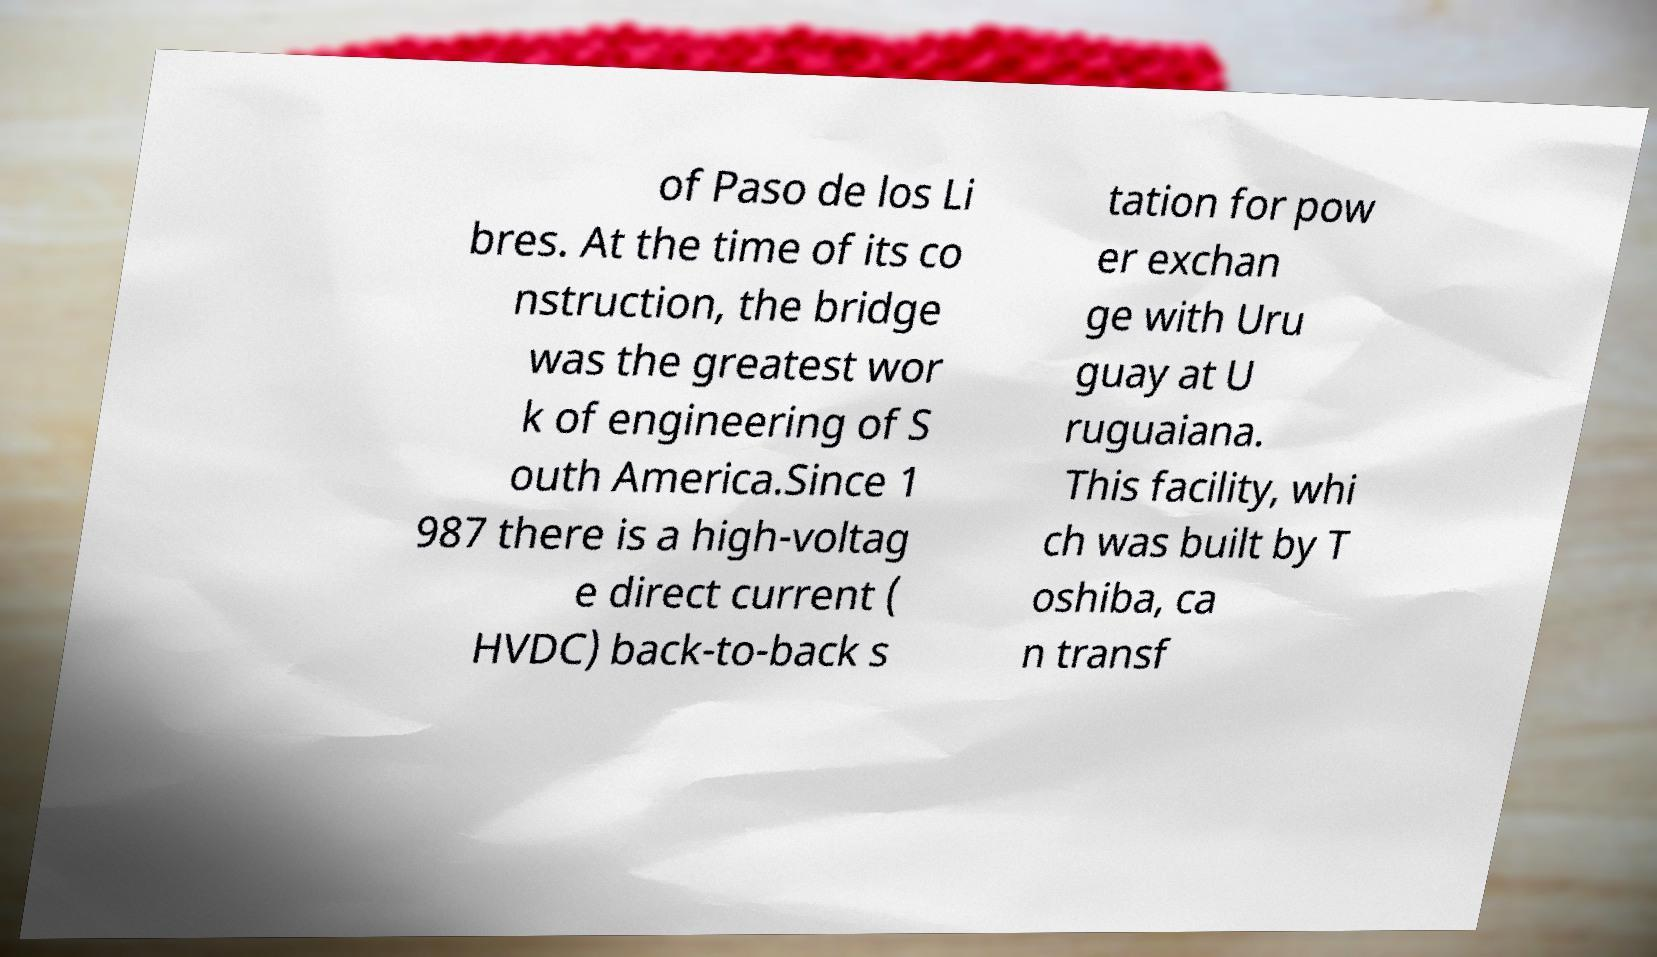I need the written content from this picture converted into text. Can you do that? of Paso de los Li bres. At the time of its co nstruction, the bridge was the greatest wor k of engineering of S outh America.Since 1 987 there is a high-voltag e direct current ( HVDC) back-to-back s tation for pow er exchan ge with Uru guay at U ruguaiana. This facility, whi ch was built by T oshiba, ca n transf 